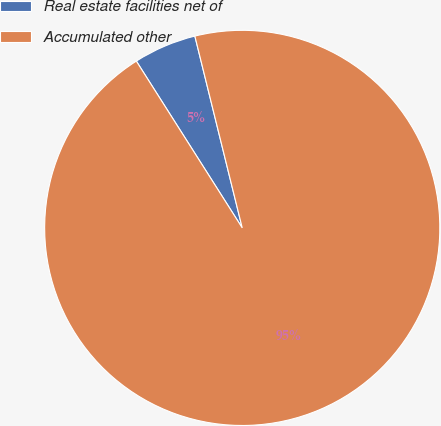<chart> <loc_0><loc_0><loc_500><loc_500><pie_chart><fcel>Real estate facilities net of<fcel>Accumulated other<nl><fcel>5.15%<fcel>94.85%<nl></chart> 